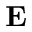<formula> <loc_0><loc_0><loc_500><loc_500>E</formula> 